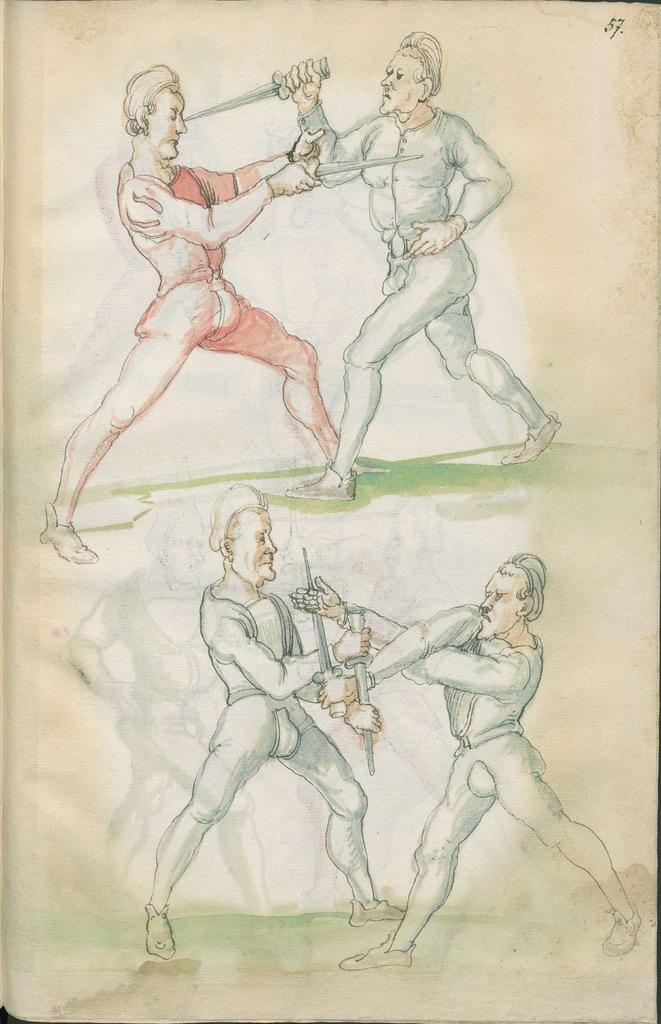Can you describe this image briefly? In this image we can see a drawing. There are four people fighting each other with swords. 